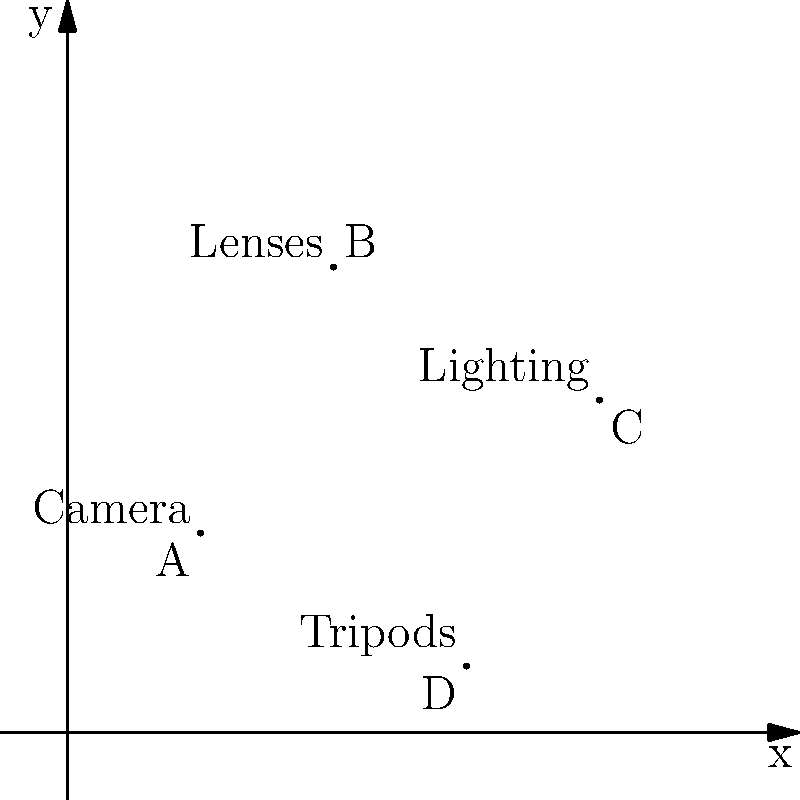You need to plot the locations of your valuable photography equipment on a grid to assess potential losses for insurance purposes. The coordinates of your equipment are: Camera (2,3), Lenses (4,7), Lighting (8,5), and Tripods (6,1). What is the total distance between the Camera and the Lighting equipment, rounded to the nearest whole number? To find the distance between the Camera and the Lighting equipment, we need to use the distance formula between two points on a coordinate plane. The formula is:

$$d = \sqrt{(x_2 - x_1)^2 + (y_2 - y_1)^2}$$

Where $(x_1, y_1)$ is the location of the Camera and $(x_2, y_2)$ is the location of the Lighting equipment.

Step 1: Identify the coordinates
Camera: (2,3)
Lighting: (8,5)

Step 2: Plug the values into the distance formula
$$d = \sqrt{(8 - 2)^2 + (5 - 3)^2}$$

Step 3: Simplify the expressions inside the parentheses
$$d = \sqrt{6^2 + 2^2}$$

Step 4: Calculate the squares
$$d = \sqrt{36 + 4}$$

Step 5: Add the values under the square root
$$d = \sqrt{40}$$

Step 6: Simplify the square root
$$d = 2\sqrt{10} \approx 6.32$$

Step 7: Round to the nearest whole number
6.32 rounds to 6

Therefore, the total distance between the Camera and the Lighting equipment, rounded to the nearest whole number, is 6 units.
Answer: 6 units 